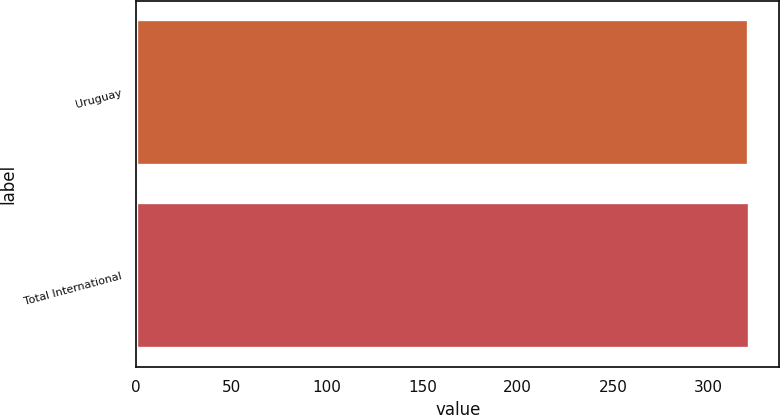Convert chart. <chart><loc_0><loc_0><loc_500><loc_500><bar_chart><fcel>Uruguay<fcel>Total International<nl><fcel>321<fcel>321.1<nl></chart> 